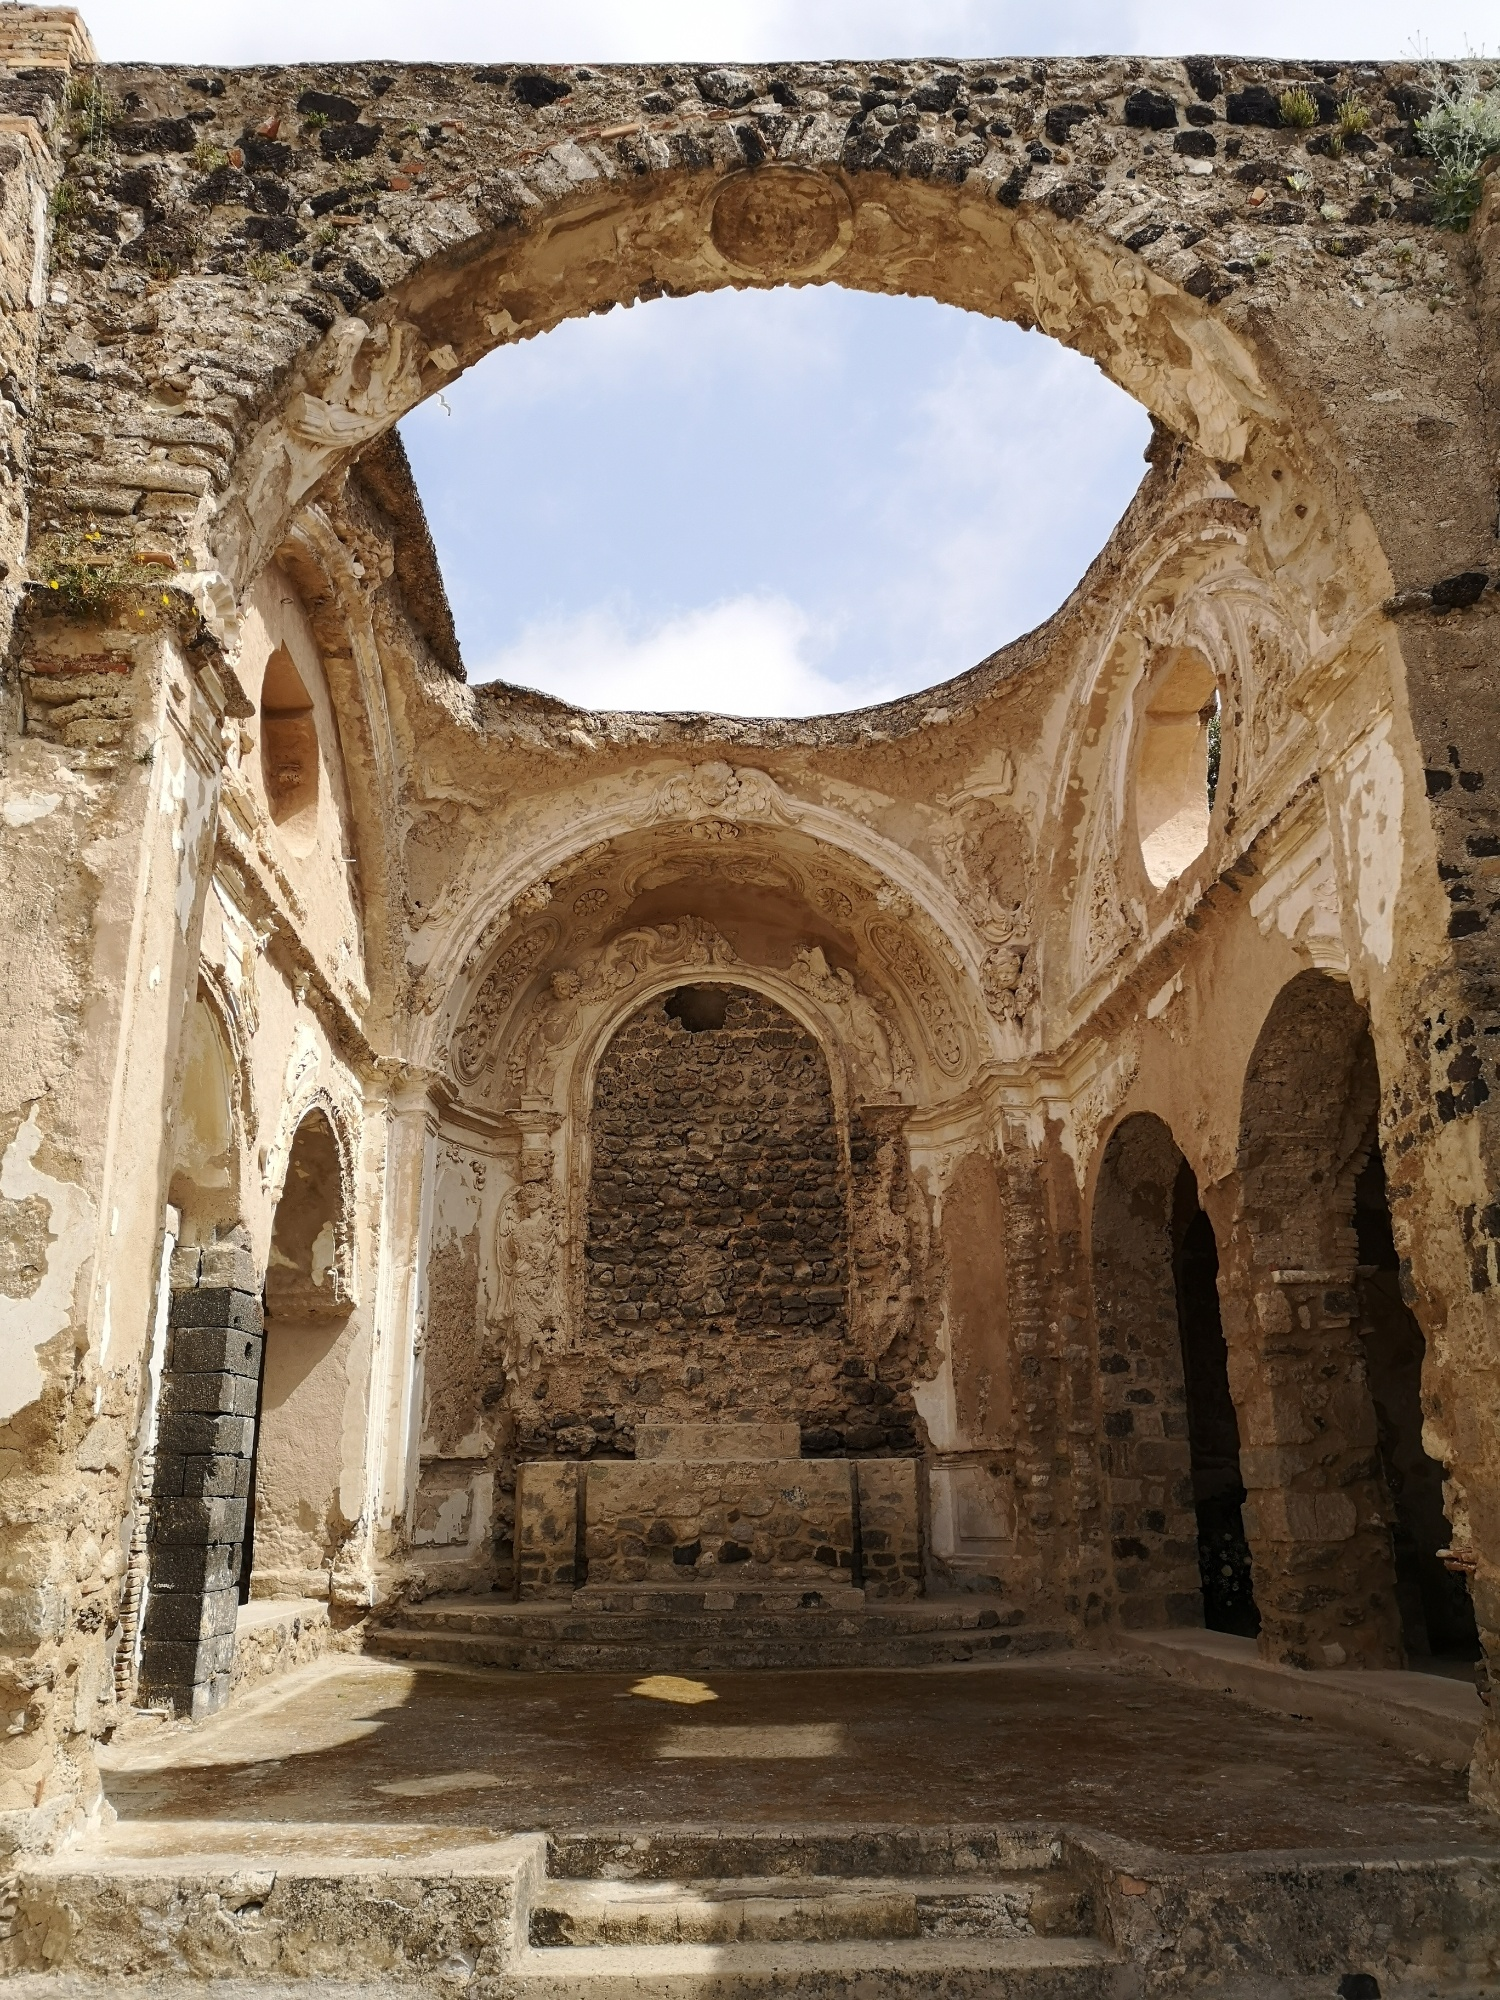Describe what you see in just one sentence. The image depicts the interior of a majestic, ancient ruin with grand stone arches and intricate carvings, open to the bright sky above. Could this structure serve any modern purpose? Yes, this structure could be repurposed as a historical site for tourism, a venue for cultural events and artistic performances, or even a serene place for contemplation and community gatherings, preserving its heritage while adapting to contemporary uses. 